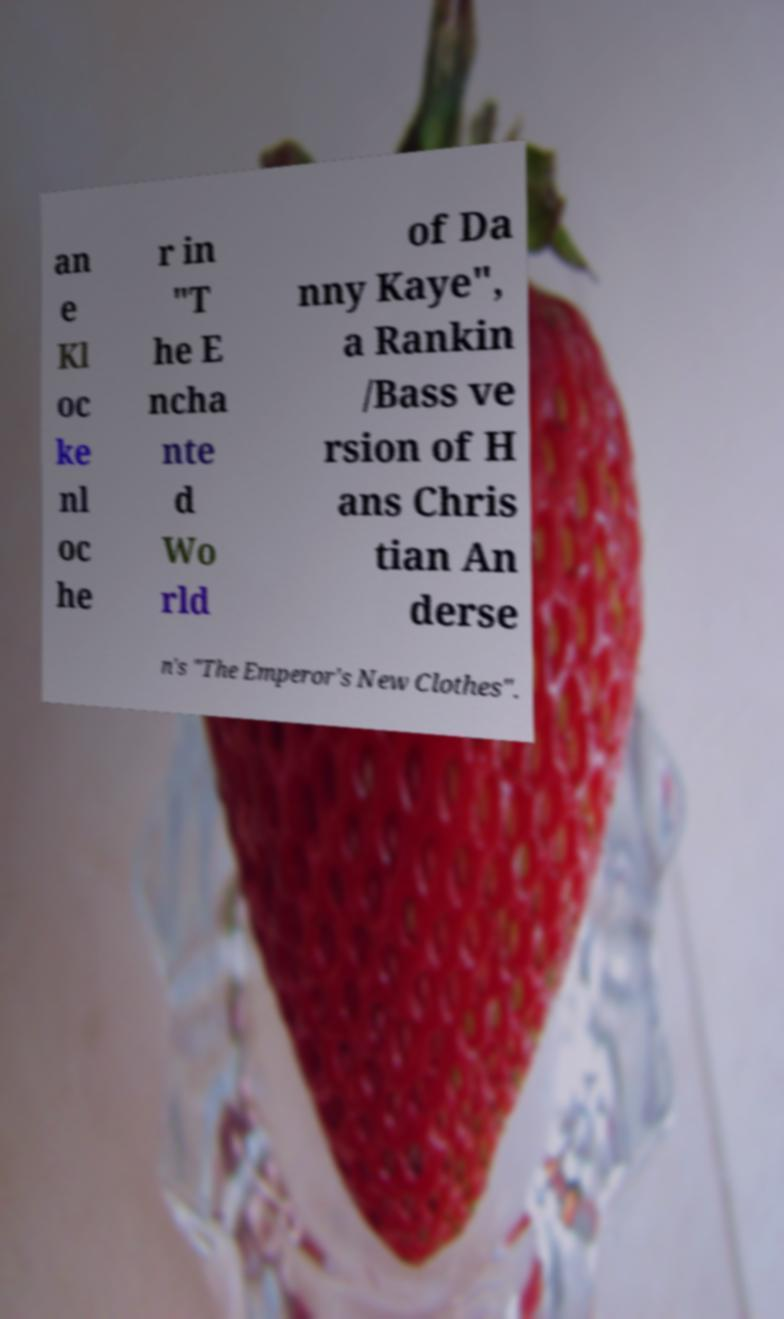I need the written content from this picture converted into text. Can you do that? an e Kl oc ke nl oc he r in "T he E ncha nte d Wo rld of Da nny Kaye", a Rankin /Bass ve rsion of H ans Chris tian An derse n's "The Emperor's New Clothes". 